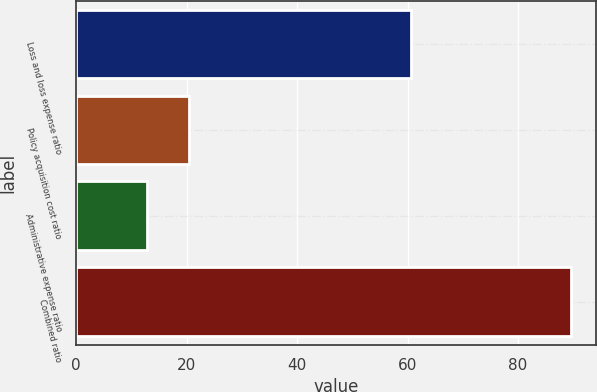Convert chart. <chart><loc_0><loc_0><loc_500><loc_500><bar_chart><fcel>Loss and loss expense ratio<fcel>Policy acquisition cost ratio<fcel>Administrative expense ratio<fcel>Combined ratio<nl><fcel>60.6<fcel>20.48<fcel>12.8<fcel>89.6<nl></chart> 